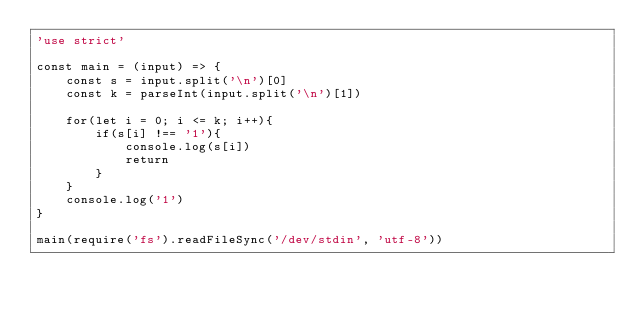Convert code to text. <code><loc_0><loc_0><loc_500><loc_500><_JavaScript_>'use strict'

const main = (input) => {
    const s = input.split('\n')[0]
    const k = parseInt(input.split('\n')[1])

    for(let i = 0; i <= k; i++){
        if(s[i] !== '1'){
            console.log(s[i])
            return
        }
    }
    console.log('1')
}

main(require('fs').readFileSync('/dev/stdin', 'utf-8'))</code> 